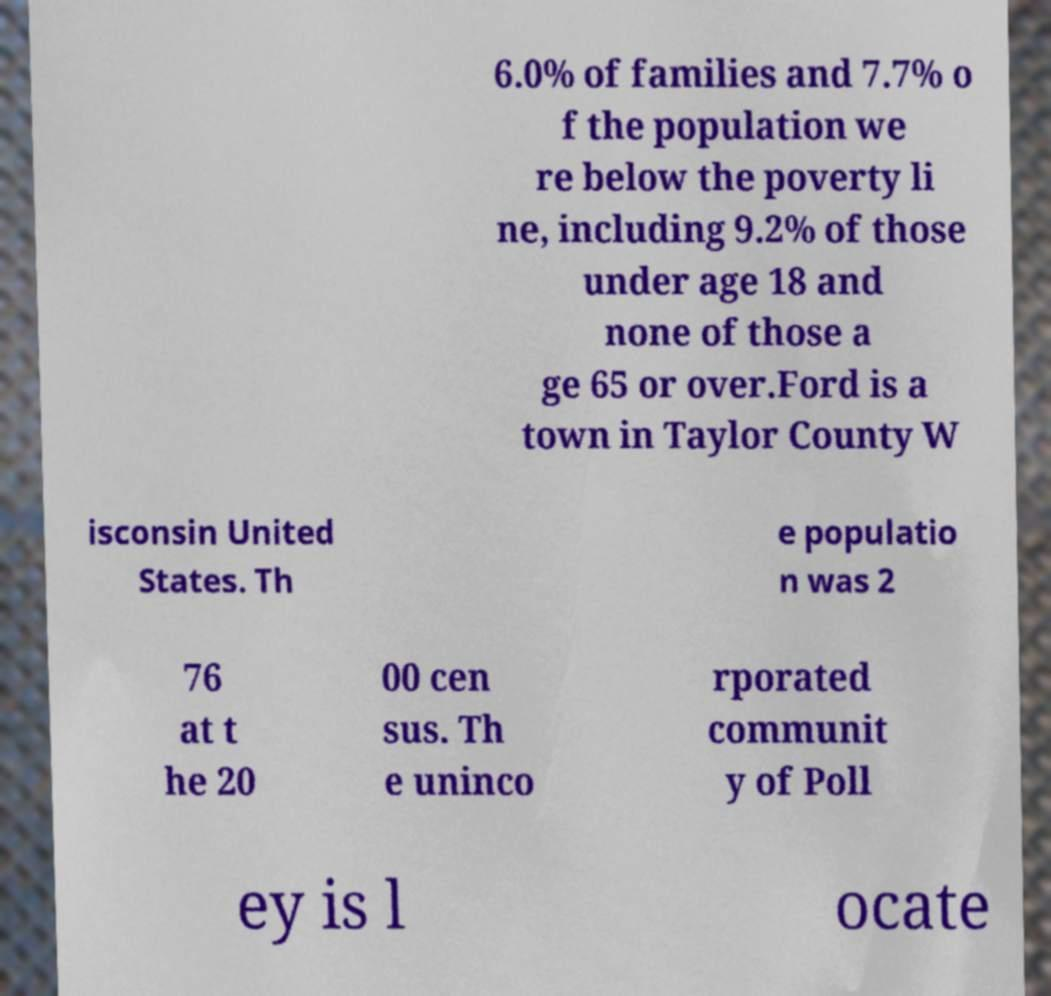There's text embedded in this image that I need extracted. Can you transcribe it verbatim? 6.0% of families and 7.7% o f the population we re below the poverty li ne, including 9.2% of those under age 18 and none of those a ge 65 or over.Ford is a town in Taylor County W isconsin United States. Th e populatio n was 2 76 at t he 20 00 cen sus. Th e uninco rporated communit y of Poll ey is l ocate 